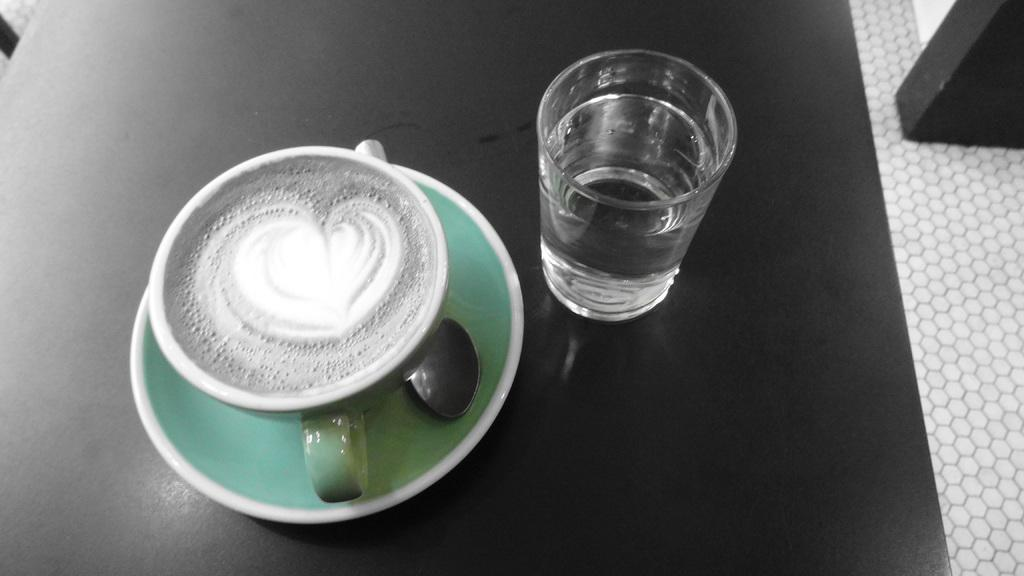What type of beverage container is present in the image? There is a coffee cup in the image. What other type of beverage container is present in the image? There is a glass of water in the image. Where are the coffee cup and the glass of water located in the image? Both the coffee cup and the glass of water are placed on a table. What type of sugar is being used to sweeten the coffee in the image? There is no sugar present in the image, nor is there any indication that the coffee is being sweetened. Where is the stove located in the image? There is no stove present in the image. 